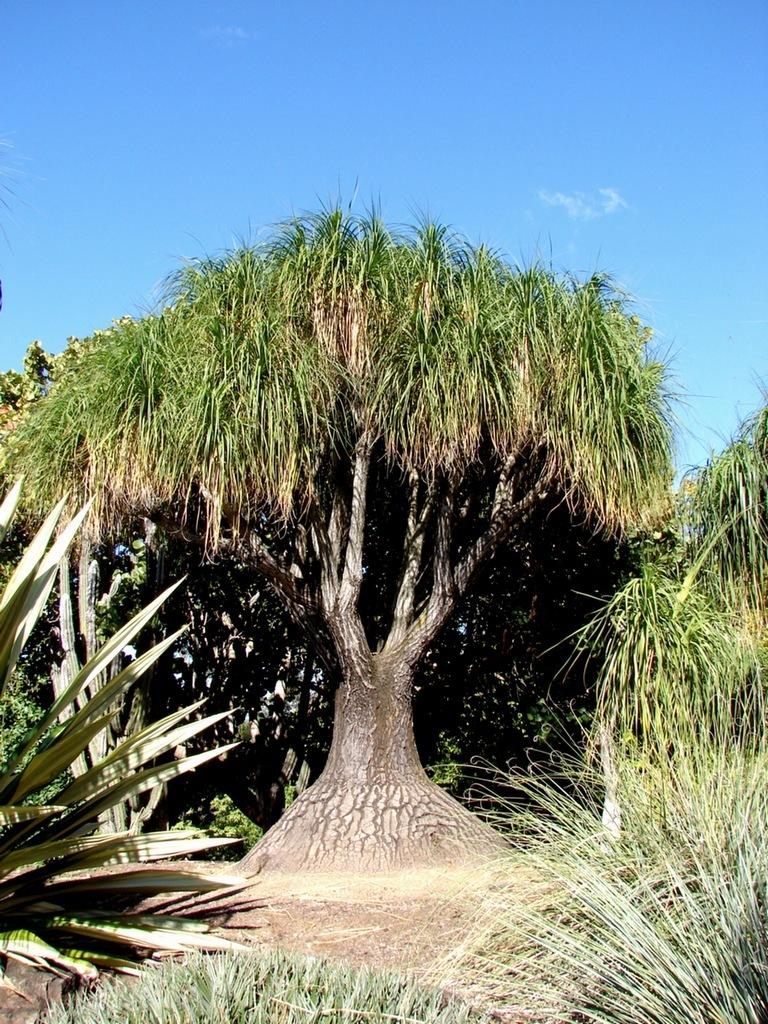What type of vegetation can be seen in the image? There are trees in the image. What color is the sky in the image? The sky is blue in the image. How many servants are present in the image? There are no servants present in the image. What type of silver object can be seen in the image? There is no silver object present in the image. 